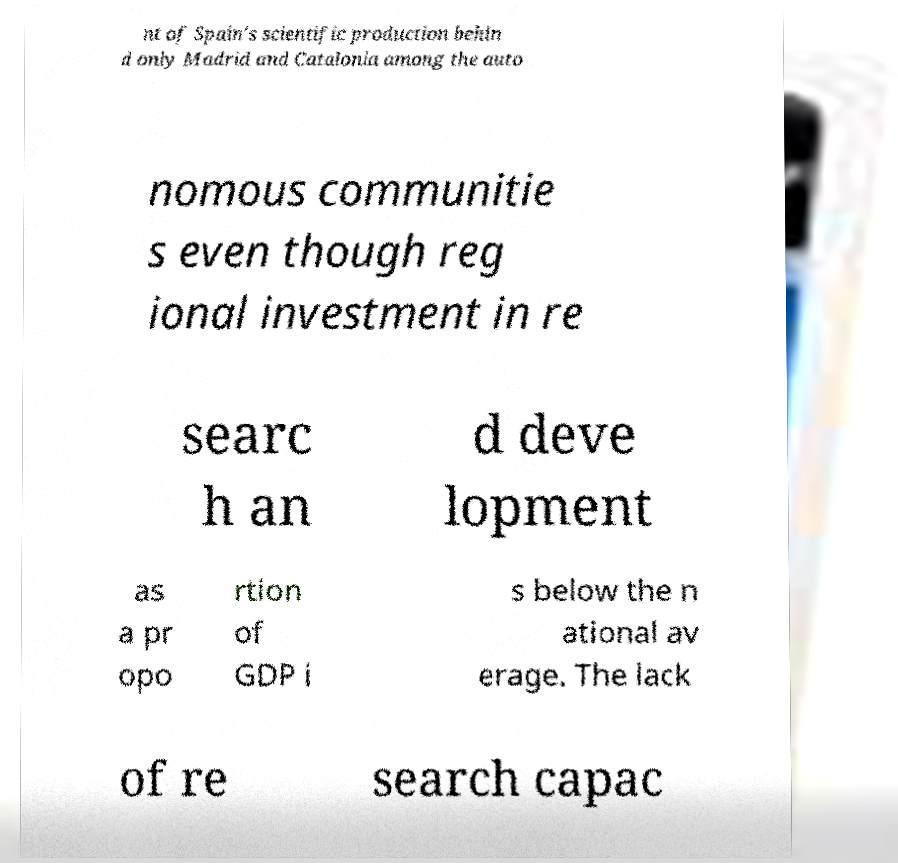Please identify and transcribe the text found in this image. nt of Spain's scientific production behin d only Madrid and Catalonia among the auto nomous communitie s even though reg ional investment in re searc h an d deve lopment as a pr opo rtion of GDP i s below the n ational av erage. The lack of re search capac 